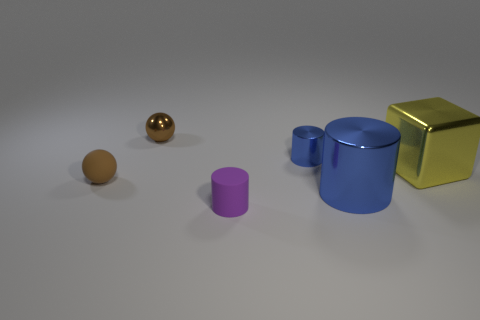Do the tiny thing that is right of the small purple cylinder and the shiny cylinder on the right side of the small blue metallic cylinder have the same color?
Provide a succinct answer. Yes. Is the material of the tiny brown object left of the small brown shiny ball the same as the small cylinder that is right of the purple cylinder?
Give a very brief answer. No. How many shiny cubes are the same size as the metallic sphere?
Provide a short and direct response. 0. Are there fewer tiny red rubber cylinders than brown shiny spheres?
Offer a terse response. Yes. The tiny object that is left of the small shiny thing left of the purple thing is what shape?
Provide a succinct answer. Sphere. There is another brown object that is the same size as the brown metallic thing; what is its shape?
Offer a terse response. Sphere. Are there any other tiny metal objects of the same shape as the small purple thing?
Offer a terse response. Yes. What is the small purple thing made of?
Offer a very short reply. Rubber. There is a large shiny cube; are there any tiny metal things left of it?
Offer a very short reply. Yes. How many blue objects are in front of the metal thing that is to the left of the purple cylinder?
Ensure brevity in your answer.  2. 